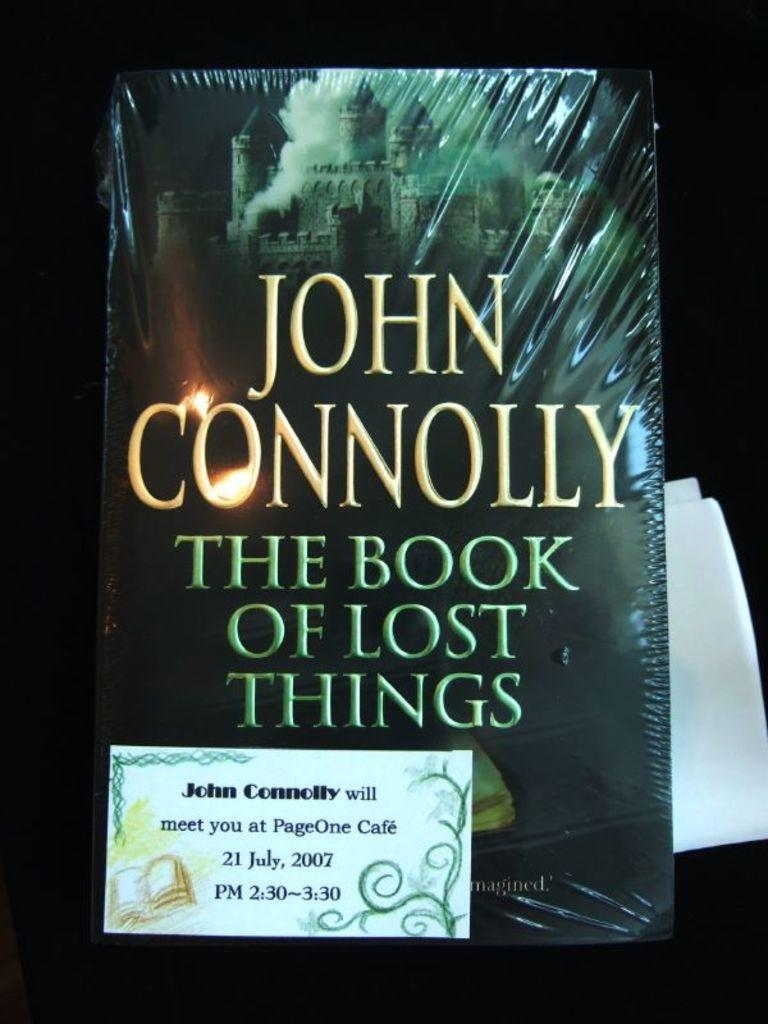<image>
Render a clear and concise summary of the photo. A John Connolly book, with the title The book of Lost Things 